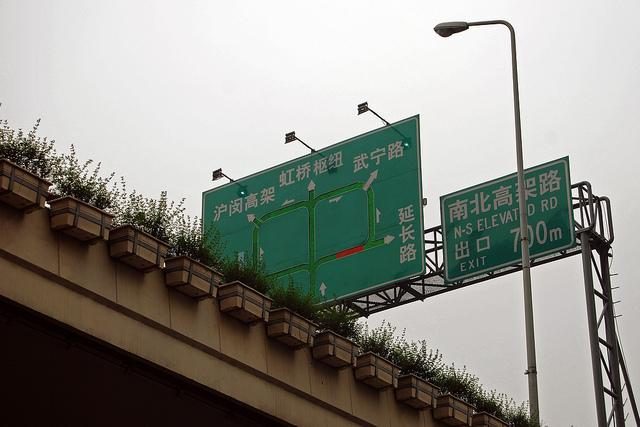According to the evidence up above where might you find the cameraman? Please explain your reasoning. china. Chinese text is shown on the signs. 